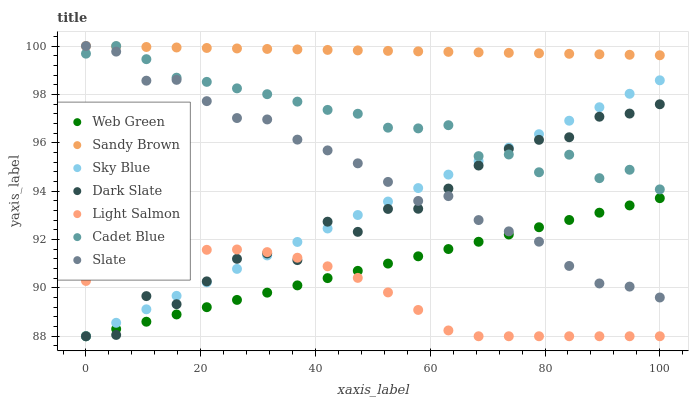Does Light Salmon have the minimum area under the curve?
Answer yes or no. Yes. Does Sandy Brown have the maximum area under the curve?
Answer yes or no. Yes. Does Cadet Blue have the minimum area under the curve?
Answer yes or no. No. Does Cadet Blue have the maximum area under the curve?
Answer yes or no. No. Is Sandy Brown the smoothest?
Answer yes or no. Yes. Is Dark Slate the roughest?
Answer yes or no. Yes. Is Cadet Blue the smoothest?
Answer yes or no. No. Is Cadet Blue the roughest?
Answer yes or no. No. Does Light Salmon have the lowest value?
Answer yes or no. Yes. Does Cadet Blue have the lowest value?
Answer yes or no. No. Does Sandy Brown have the highest value?
Answer yes or no. Yes. Does Web Green have the highest value?
Answer yes or no. No. Is Web Green less than Cadet Blue?
Answer yes or no. Yes. Is Cadet Blue greater than Light Salmon?
Answer yes or no. Yes. Does Sky Blue intersect Light Salmon?
Answer yes or no. Yes. Is Sky Blue less than Light Salmon?
Answer yes or no. No. Is Sky Blue greater than Light Salmon?
Answer yes or no. No. Does Web Green intersect Cadet Blue?
Answer yes or no. No. 